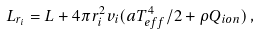Convert formula to latex. <formula><loc_0><loc_0><loc_500><loc_500>L _ { r _ { i } } = L + 4 \pi r _ { i } ^ { 2 } v _ { i } ( a T _ { e f f } ^ { 4 } / 2 + \rho Q _ { i o n } ) \, ,</formula> 